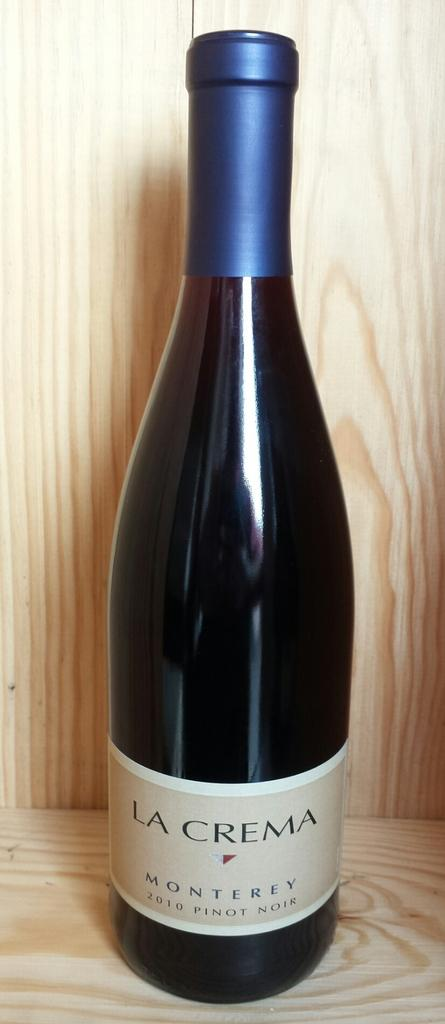<image>
Give a short and clear explanation of the subsequent image. A sealed bottle of La Crema Monterey is standing on a wooden display. 